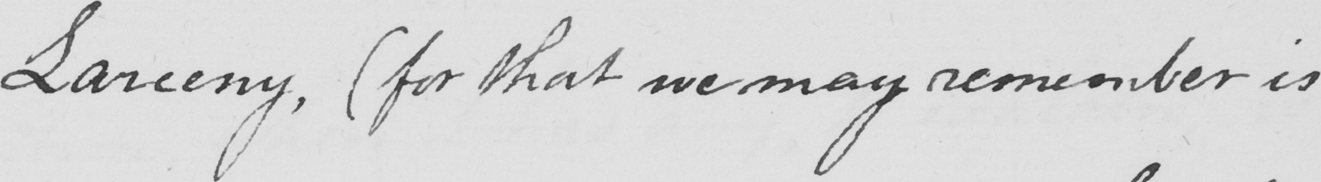What does this handwritten line say? Larceny ,  ( for that we may remember is 